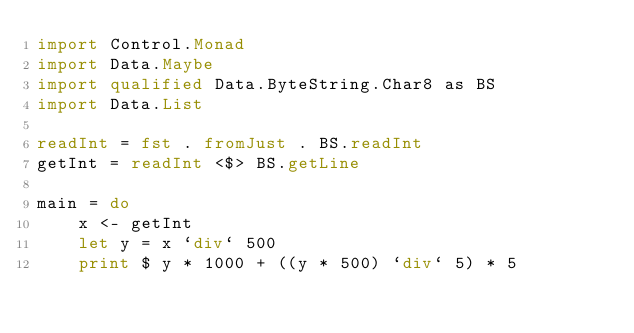<code> <loc_0><loc_0><loc_500><loc_500><_Haskell_>import Control.Monad
import Data.Maybe
import qualified Data.ByteString.Char8 as BS
import Data.List

readInt = fst . fromJust . BS.readInt
getInt = readInt <$> BS.getLine

main = do
    x <- getInt
    let y = x `div` 500
    print $ y * 1000 + ((y * 500) `div` 5) * 5</code> 